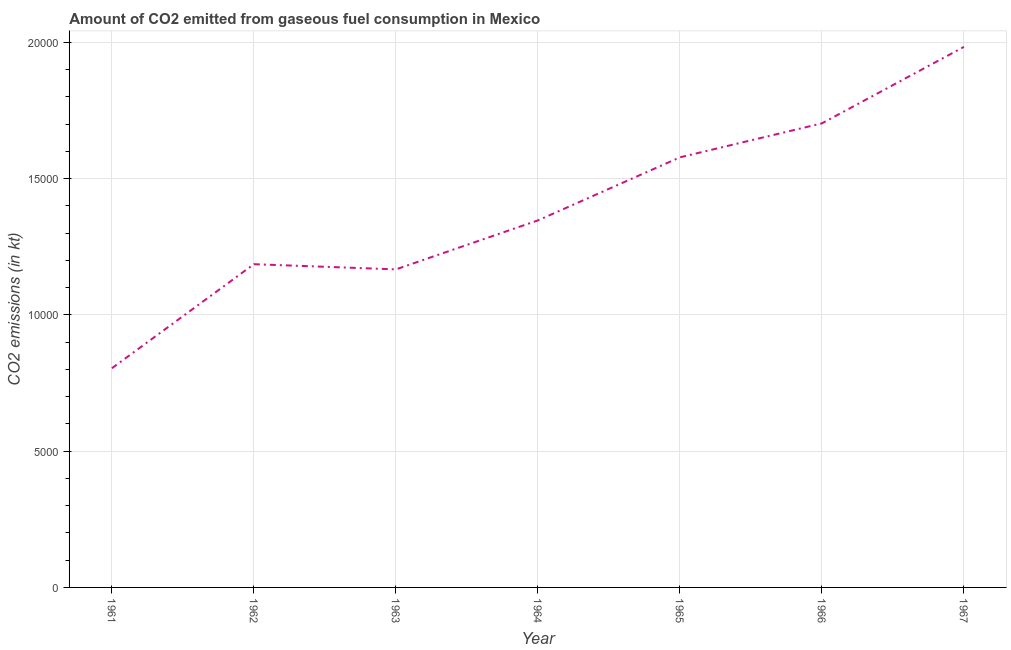What is the co2 emissions from gaseous fuel consumption in 1961?
Your response must be concise. 8041.73. Across all years, what is the maximum co2 emissions from gaseous fuel consumption?
Offer a very short reply. 1.98e+04. Across all years, what is the minimum co2 emissions from gaseous fuel consumption?
Ensure brevity in your answer.  8041.73. In which year was the co2 emissions from gaseous fuel consumption maximum?
Give a very brief answer. 1967. What is the sum of the co2 emissions from gaseous fuel consumption?
Your answer should be compact. 9.77e+04. What is the difference between the co2 emissions from gaseous fuel consumption in 1963 and 1966?
Keep it short and to the point. -5357.49. What is the average co2 emissions from gaseous fuel consumption per year?
Your answer should be very brief. 1.40e+04. What is the median co2 emissions from gaseous fuel consumption?
Ensure brevity in your answer.  1.35e+04. Do a majority of the years between 1967 and 1966 (inclusive) have co2 emissions from gaseous fuel consumption greater than 17000 kt?
Make the answer very short. No. What is the ratio of the co2 emissions from gaseous fuel consumption in 1962 to that in 1967?
Your answer should be very brief. 0.6. Is the co2 emissions from gaseous fuel consumption in 1966 less than that in 1967?
Keep it short and to the point. Yes. What is the difference between the highest and the second highest co2 emissions from gaseous fuel consumption?
Your answer should be very brief. 2805.25. What is the difference between the highest and the lowest co2 emissions from gaseous fuel consumption?
Give a very brief answer. 1.18e+04. Does the co2 emissions from gaseous fuel consumption monotonically increase over the years?
Offer a terse response. No. How many lines are there?
Give a very brief answer. 1. How many years are there in the graph?
Make the answer very short. 7. What is the difference between two consecutive major ticks on the Y-axis?
Offer a terse response. 5000. Does the graph contain grids?
Make the answer very short. Yes. What is the title of the graph?
Provide a succinct answer. Amount of CO2 emitted from gaseous fuel consumption in Mexico. What is the label or title of the Y-axis?
Make the answer very short. CO2 emissions (in kt). What is the CO2 emissions (in kt) in 1961?
Offer a terse response. 8041.73. What is the CO2 emissions (in kt) in 1962?
Your answer should be very brief. 1.19e+04. What is the CO2 emissions (in kt) in 1963?
Keep it short and to the point. 1.17e+04. What is the CO2 emissions (in kt) of 1964?
Your response must be concise. 1.35e+04. What is the CO2 emissions (in kt) of 1965?
Your answer should be very brief. 1.58e+04. What is the CO2 emissions (in kt) of 1966?
Your response must be concise. 1.70e+04. What is the CO2 emissions (in kt) in 1967?
Provide a succinct answer. 1.98e+04. What is the difference between the CO2 emissions (in kt) in 1961 and 1962?
Keep it short and to the point. -3817.35. What is the difference between the CO2 emissions (in kt) in 1961 and 1963?
Make the answer very short. -3626.66. What is the difference between the CO2 emissions (in kt) in 1961 and 1964?
Your answer should be compact. -5423.49. What is the difference between the CO2 emissions (in kt) in 1961 and 1965?
Give a very brief answer. -7737.37. What is the difference between the CO2 emissions (in kt) in 1961 and 1966?
Provide a short and direct response. -8984.15. What is the difference between the CO2 emissions (in kt) in 1961 and 1967?
Provide a short and direct response. -1.18e+04. What is the difference between the CO2 emissions (in kt) in 1962 and 1963?
Offer a very short reply. 190.68. What is the difference between the CO2 emissions (in kt) in 1962 and 1964?
Your answer should be compact. -1606.15. What is the difference between the CO2 emissions (in kt) in 1962 and 1965?
Your answer should be compact. -3920.02. What is the difference between the CO2 emissions (in kt) in 1962 and 1966?
Keep it short and to the point. -5166.8. What is the difference between the CO2 emissions (in kt) in 1962 and 1967?
Provide a succinct answer. -7972.06. What is the difference between the CO2 emissions (in kt) in 1963 and 1964?
Offer a terse response. -1796.83. What is the difference between the CO2 emissions (in kt) in 1963 and 1965?
Give a very brief answer. -4110.71. What is the difference between the CO2 emissions (in kt) in 1963 and 1966?
Make the answer very short. -5357.49. What is the difference between the CO2 emissions (in kt) in 1963 and 1967?
Offer a very short reply. -8162.74. What is the difference between the CO2 emissions (in kt) in 1964 and 1965?
Your response must be concise. -2313.88. What is the difference between the CO2 emissions (in kt) in 1964 and 1966?
Offer a very short reply. -3560.66. What is the difference between the CO2 emissions (in kt) in 1964 and 1967?
Offer a very short reply. -6365.91. What is the difference between the CO2 emissions (in kt) in 1965 and 1966?
Provide a succinct answer. -1246.78. What is the difference between the CO2 emissions (in kt) in 1965 and 1967?
Make the answer very short. -4052.03. What is the difference between the CO2 emissions (in kt) in 1966 and 1967?
Provide a short and direct response. -2805.26. What is the ratio of the CO2 emissions (in kt) in 1961 to that in 1962?
Your response must be concise. 0.68. What is the ratio of the CO2 emissions (in kt) in 1961 to that in 1963?
Give a very brief answer. 0.69. What is the ratio of the CO2 emissions (in kt) in 1961 to that in 1964?
Keep it short and to the point. 0.6. What is the ratio of the CO2 emissions (in kt) in 1961 to that in 1965?
Make the answer very short. 0.51. What is the ratio of the CO2 emissions (in kt) in 1961 to that in 1966?
Provide a short and direct response. 0.47. What is the ratio of the CO2 emissions (in kt) in 1961 to that in 1967?
Your answer should be very brief. 0.41. What is the ratio of the CO2 emissions (in kt) in 1962 to that in 1963?
Your answer should be compact. 1.02. What is the ratio of the CO2 emissions (in kt) in 1962 to that in 1964?
Provide a succinct answer. 0.88. What is the ratio of the CO2 emissions (in kt) in 1962 to that in 1965?
Provide a short and direct response. 0.75. What is the ratio of the CO2 emissions (in kt) in 1962 to that in 1966?
Ensure brevity in your answer.  0.7. What is the ratio of the CO2 emissions (in kt) in 1962 to that in 1967?
Offer a very short reply. 0.6. What is the ratio of the CO2 emissions (in kt) in 1963 to that in 1964?
Your answer should be very brief. 0.87. What is the ratio of the CO2 emissions (in kt) in 1963 to that in 1965?
Provide a short and direct response. 0.74. What is the ratio of the CO2 emissions (in kt) in 1963 to that in 1966?
Your answer should be very brief. 0.69. What is the ratio of the CO2 emissions (in kt) in 1963 to that in 1967?
Your answer should be compact. 0.59. What is the ratio of the CO2 emissions (in kt) in 1964 to that in 1965?
Your response must be concise. 0.85. What is the ratio of the CO2 emissions (in kt) in 1964 to that in 1966?
Your answer should be very brief. 0.79. What is the ratio of the CO2 emissions (in kt) in 1964 to that in 1967?
Your answer should be very brief. 0.68. What is the ratio of the CO2 emissions (in kt) in 1965 to that in 1966?
Make the answer very short. 0.93. What is the ratio of the CO2 emissions (in kt) in 1965 to that in 1967?
Your response must be concise. 0.8. What is the ratio of the CO2 emissions (in kt) in 1966 to that in 1967?
Make the answer very short. 0.86. 